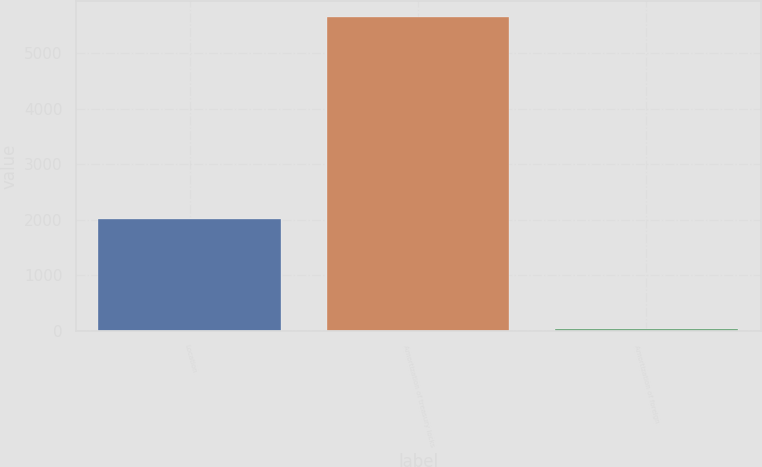<chart> <loc_0><loc_0><loc_500><loc_500><bar_chart><fcel>Location<fcel>Amortization of treasury locks<fcel>Amortization of foreign<nl><fcel>2013<fcel>5655<fcel>34<nl></chart> 